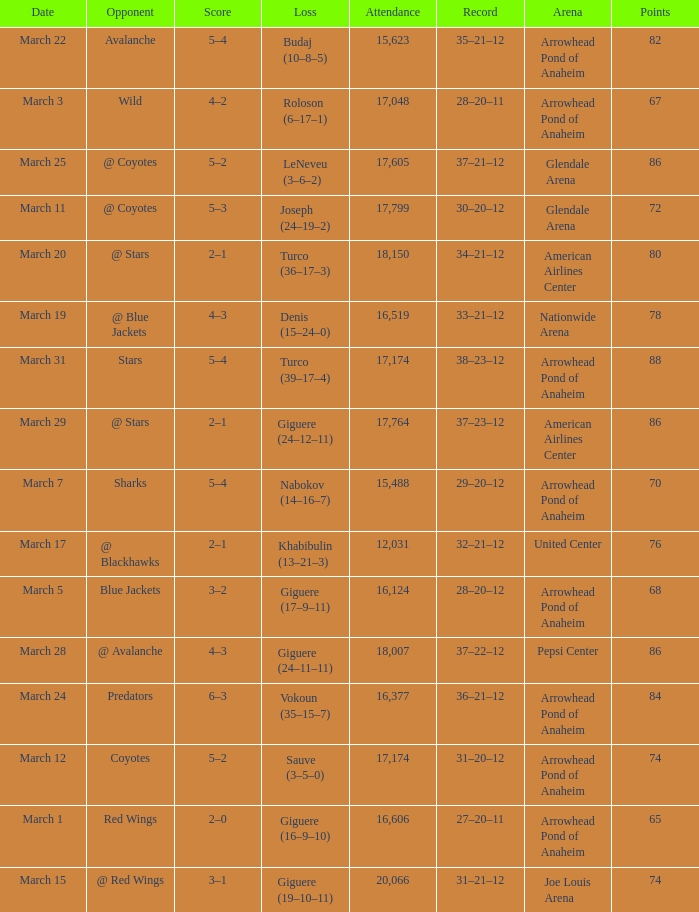Can you parse all the data within this table? {'header': ['Date', 'Opponent', 'Score', 'Loss', 'Attendance', 'Record', 'Arena', 'Points'], 'rows': [['March 22', 'Avalanche', '5–4', 'Budaj (10–8–5)', '15,623', '35–21–12', 'Arrowhead Pond of Anaheim', '82'], ['March 3', 'Wild', '4–2', 'Roloson (6–17–1)', '17,048', '28–20–11', 'Arrowhead Pond of Anaheim', '67'], ['March 25', '@ Coyotes', '5–2', 'LeNeveu (3–6–2)', '17,605', '37–21–12', 'Glendale Arena', '86'], ['March 11', '@ Coyotes', '5–3', 'Joseph (24–19–2)', '17,799', '30–20–12', 'Glendale Arena', '72'], ['March 20', '@ Stars', '2–1', 'Turco (36–17–3)', '18,150', '34–21–12', 'American Airlines Center', '80'], ['March 19', '@ Blue Jackets', '4–3', 'Denis (15–24–0)', '16,519', '33–21–12', 'Nationwide Arena', '78'], ['March 31', 'Stars', '5–4', 'Turco (39–17–4)', '17,174', '38–23–12', 'Arrowhead Pond of Anaheim', '88'], ['March 29', '@ Stars', '2–1', 'Giguere (24–12–11)', '17,764', '37–23–12', 'American Airlines Center', '86'], ['March 7', 'Sharks', '5–4', 'Nabokov (14–16–7)', '15,488', '29–20–12', 'Arrowhead Pond of Anaheim', '70'], ['March 17', '@ Blackhawks', '2–1', 'Khabibulin (13–21–3)', '12,031', '32–21–12', 'United Center', '76'], ['March 5', 'Blue Jackets', '3–2', 'Giguere (17–9–11)', '16,124', '28–20–12', 'Arrowhead Pond of Anaheim', '68'], ['March 28', '@ Avalanche', '4–3', 'Giguere (24–11–11)', '18,007', '37–22–12', 'Pepsi Center', '86'], ['March 24', 'Predators', '6–3', 'Vokoun (35–15–7)', '16,377', '36–21–12', 'Arrowhead Pond of Anaheim', '84'], ['March 12', 'Coyotes', '5–2', 'Sauve (3–5–0)', '17,174', '31–20–12', 'Arrowhead Pond of Anaheim', '74'], ['March 1', 'Red Wings', '2–0', 'Giguere (16–9–10)', '16,606', '27–20–11', 'Arrowhead Pond of Anaheim', '65'], ['March 15', '@ Red Wings', '3–1', 'Giguere (19–10–11)', '20,066', '31–21–12', 'Joe Louis Arena', '74']]} What is the Attendance of the game with a Record of 37–21–12 and less than 86 Points? None. 